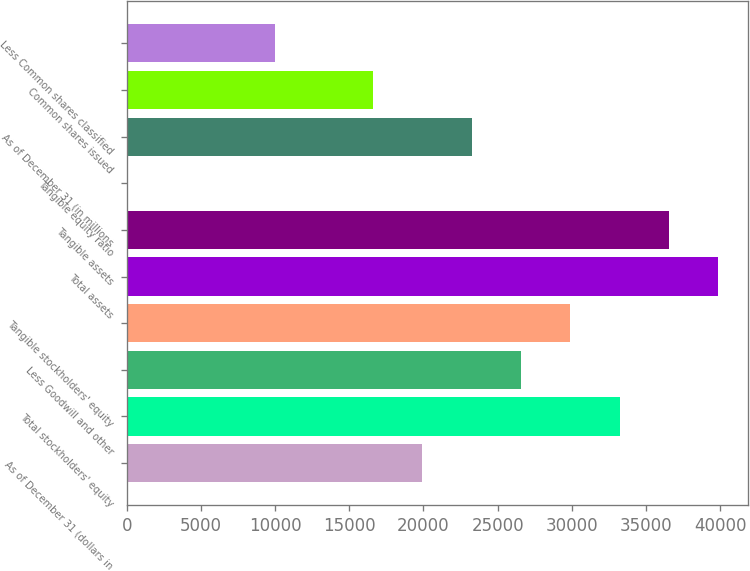Convert chart to OTSL. <chart><loc_0><loc_0><loc_500><loc_500><bar_chart><fcel>As of December 31 (dollars in<fcel>Total stockholders' equity<fcel>Less Goodwill and other<fcel>Tangible stockholders' equity<fcel>Total assets<fcel>Tangible assets<fcel>Tangible equity ratio<fcel>As of December 31 (in millions<fcel>Common shares issued<fcel>Less Common shares classified<nl><fcel>19931.6<fcel>33214<fcel>26572.8<fcel>29893.4<fcel>39855.2<fcel>36534.6<fcel>7.9<fcel>23252.2<fcel>16611<fcel>9969.73<nl></chart> 